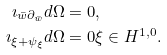Convert formula to latex. <formula><loc_0><loc_0><loc_500><loc_500>\imath _ { \bar { w } \partial _ { \bar { w } } } d \Omega & = 0 , \\ \imath _ { \xi + \psi _ { \xi } } d \Omega & = 0 \xi \in H ^ { 1 , 0 } .</formula> 